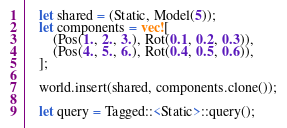Convert code to text. <code><loc_0><loc_0><loc_500><loc_500><_Rust_>
    let shared = (Static, Model(5));
    let components = vec![
        (Pos(1., 2., 3.), Rot(0.1, 0.2, 0.3)),
        (Pos(4., 5., 6.), Rot(0.4, 0.5, 0.6)),
    ];

    world.insert(shared, components.clone());

    let query = Tagged::<Static>::query();
</code> 